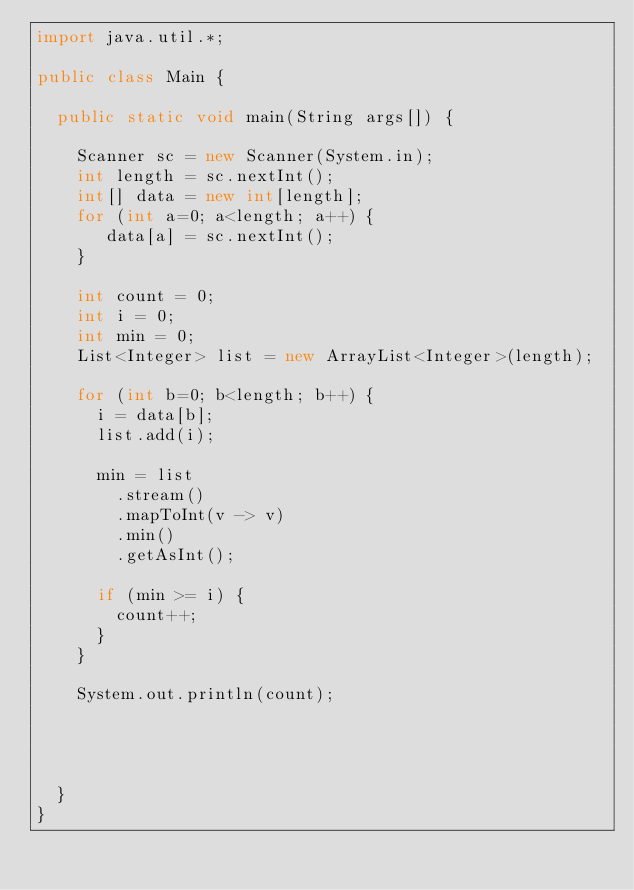<code> <loc_0><loc_0><loc_500><loc_500><_Java_>import java.util.*;

public class Main {
 
  public static void main(String args[]) {
   
    Scanner sc = new Scanner(System.in);
    int length = sc.nextInt();
    int[] data = new int[length];
    for (int a=0; a<length; a++) {
       data[a] = sc.nextInt();
    }
   
    int count = 0;
    int i = 0;
    int min = 0;
    List<Integer> list = new ArrayList<Integer>(length);
    
    for (int b=0; b<length; b++) {
      i = data[b];
      list.add(i);

      min = list
        .stream()
        .mapToInt(v -> v)
        .min()
        .getAsInt();
            
      if (min >= i) {
        count++;
      }
    }
    
    System.out.println(count);
   
     
    
    
  }
}</code> 